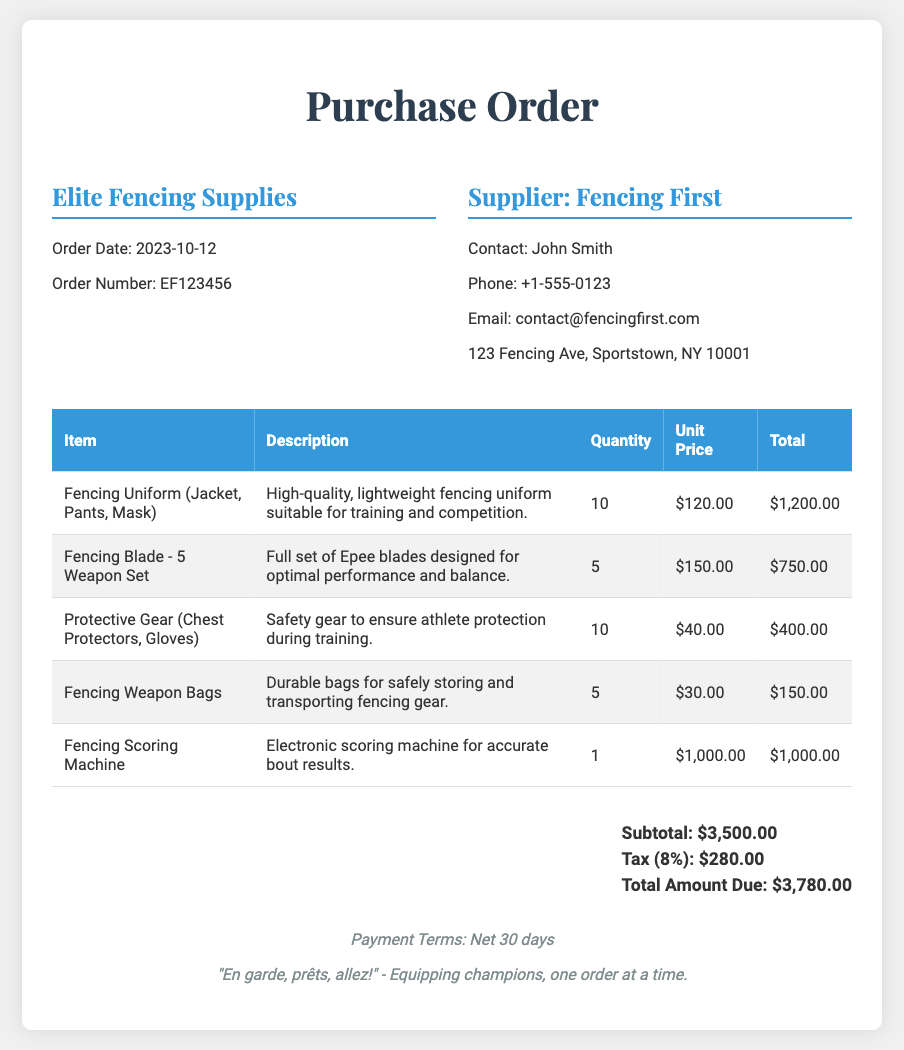What is the order date? The order date is specified in the document under company info.
Answer: 2023-10-12 What is the order number? The order number can be found in the company info section of the document.
Answer: EF123456 Who is the contact at the supplier? The contact person is mentioned in the supplier info section of the document.
Answer: John Smith What is the quantity of Fencing Uniforms ordered? The quantity of Fencing Uniforms is listed in the itemized table.
Answer: 10 What is the total amount due? The total amount due can be found at the end of the total section in the document.
Answer: $3,780.00 What is the subtotal before tax? The subtotal is noted in the total section as the sum of all item totals.
Answer: $3,500.00 How many Fencing Weapon Bags were ordered? The number of Fencing Weapon Bags is listed in the itemized table of the document.
Answer: 5 What type of gear is included in the protective gear? The protective gear description indicates what is included.
Answer: Chest Protectors, Gloves What is the tax percentage applied to this order? The tax percentage is explicitly stated in the total section of the document.
Answer: 8% What is the payment term mentioned? The payment terms are noted in the footer of the document.
Answer: Net 30 days 